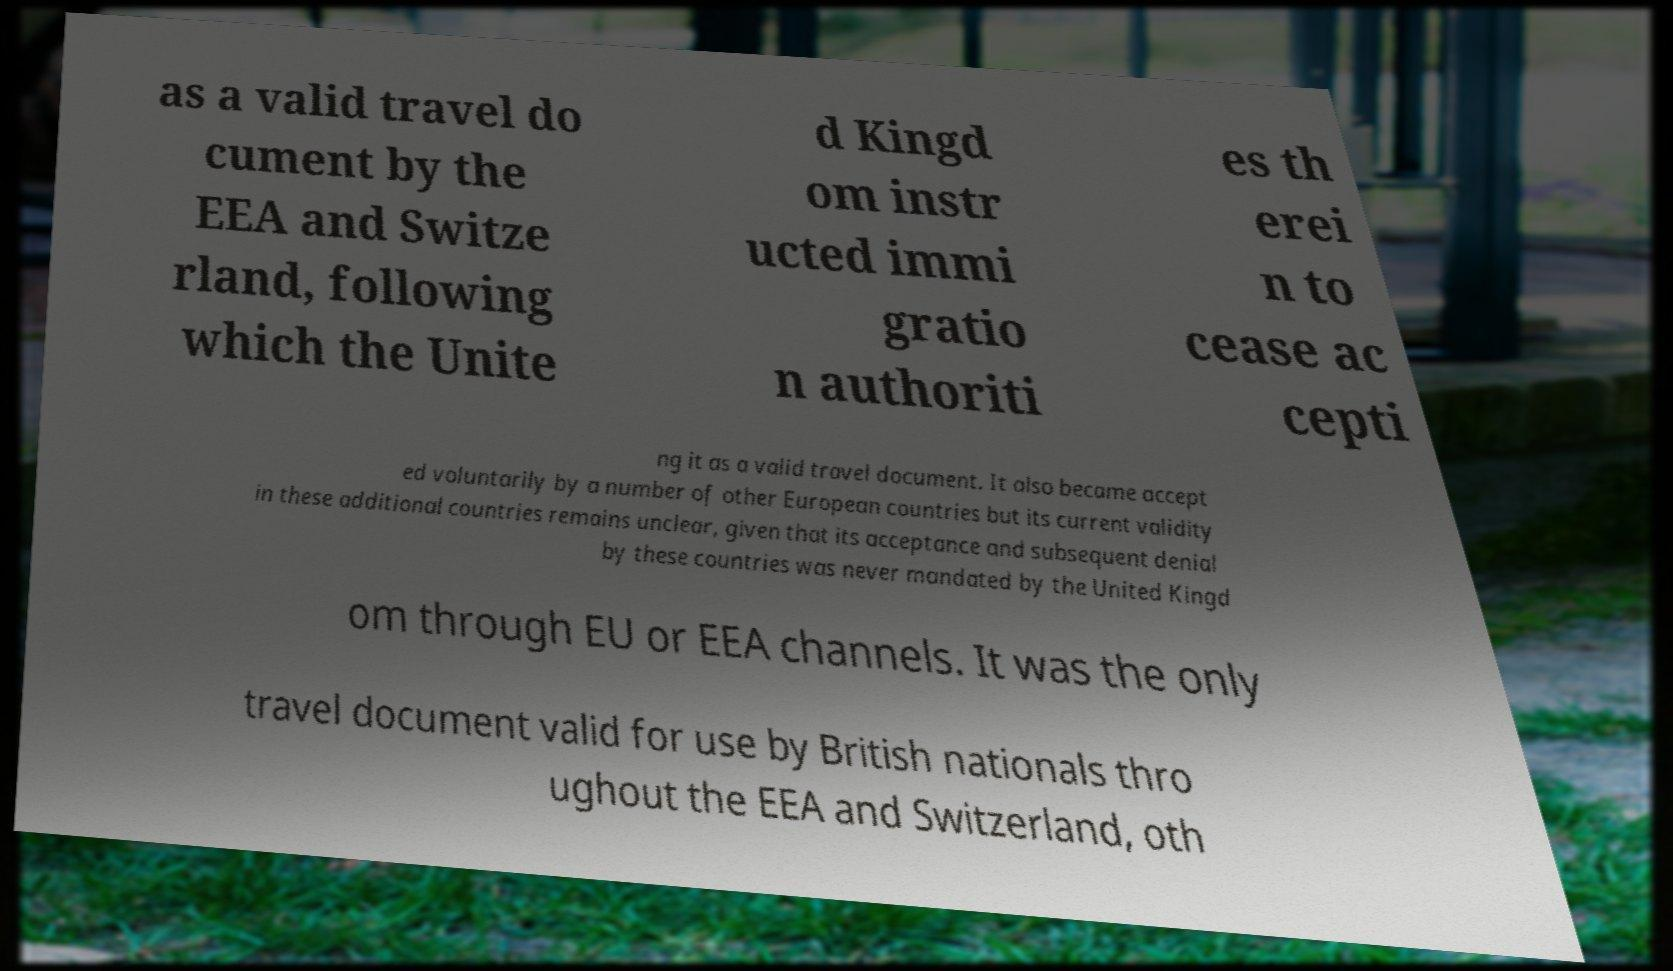Could you assist in decoding the text presented in this image and type it out clearly? as a valid travel do cument by the EEA and Switze rland, following which the Unite d Kingd om instr ucted immi gratio n authoriti es th erei n to cease ac cepti ng it as a valid travel document. It also became accept ed voluntarily by a number of other European countries but its current validity in these additional countries remains unclear, given that its acceptance and subsequent denial by these countries was never mandated by the United Kingd om through EU or EEA channels. It was the only travel document valid for use by British nationals thro ughout the EEA and Switzerland, oth 